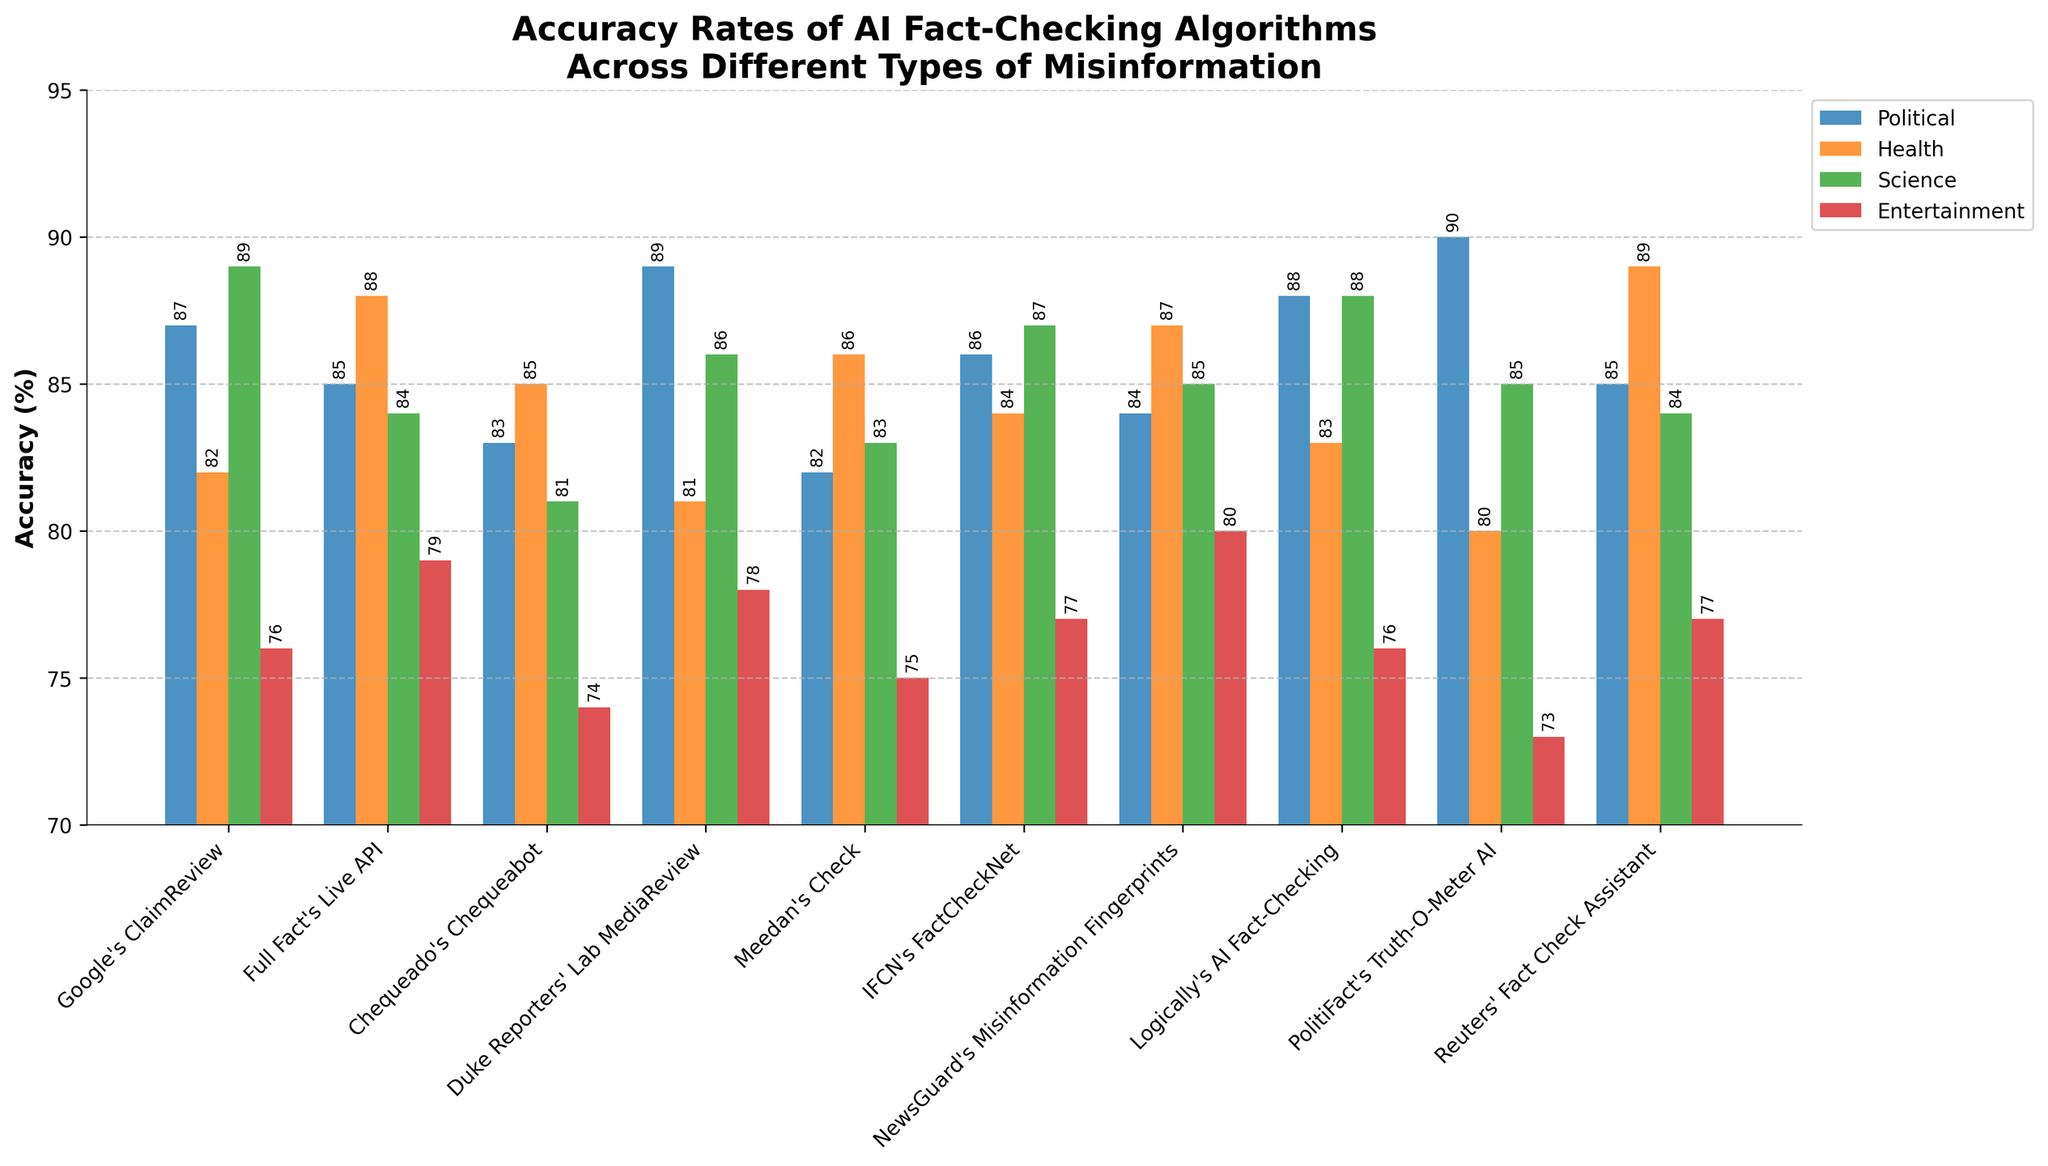Which algorithm has the highest accuracy rate for political misinformation? To find the highest accuracy rate for political misinformation, look at the heights (values) of the blue bars. Identify the tallest blue bar which corresponds to PolitiFact’s Truth-O-Meter AI.
Answer: PolitiFact's Truth-O-Meter AI Which algorithm is closest to achieving an 85% accuracy rate across all types of misinformation? To determine this, average the accuracy rates for each algorithm and compare the averaged value to 85%. The algorithm closest to this average is Reuters' Fact Check Assistant (85+89+84+77)/4 = 83.75.
Answer: Reuters' Fact Check Assistant Which category of misinformation shows the highest variance in accuracy rates among the algorithms? Find the range (difference between the highest and lowest values) for each category by identifying the highest and lowest values for each group's colored bar: Political has a range of 90-82=8, Health has 89-80=9, Science has 89-81=8, and Entertainment has 80-73=7. Health has the highest variance.
Answer: Health Among Google's ClaimReview and Logically's AI Fact-Checking, which has a higher accuracy rate for health-related misinformation? Compare the heights of the orange bars for these two algorithms. Logically's AI Fact-Checking has an accuracy rate of 83%, whereas Google's ClaimReview has an accuracy rate of 82%.
Answer: Logically's AI Fact-Checking Which type of misinformation has the lowest average accuracy rate across all algorithms? Compute the average accuracy rate for each type of misinformation: Political: (87+85+83+89+82+86+84+88+90+85)/10=85.9, Health: (82+88+85+81+86+84+87+83+80+89)/10=84.5, Science: (89+84+81+86+83+87+85+88+85+84)/10=85.2, Entertainment: (76+79+74+78+75+77+80+76+73+77)/10=76.5. Entertainment has the lowest average accuracy rate.
Answer: Entertainment For which type of misinformation does Duke Reporters' Lab MediaReview have the highest accuracy rate when compared to other algorithms? Compare Duke Reporters' Lab MediaReview's accuracy rates across all types of misinformation. For each type, check if its value is the highest compared to others. It has the highest rate in the Political category with 89%.
Answer: Political Does Full Fact's Live API have a higher accuracy rate for health misinformation compared to science misinformation? Compare the heights of the orange and green bars for Full Fact's Live API. The health accuracy rate is 88%, and the science accuracy rate is 84%.
Answer: Yes What is the difference in accuracy rates for political misinformation between Chequeado's Chequeabot and Meedan's Check? Identify the heights of the blue bars for Chequeado's Chequeabot and Meedan's Check. Chequeado's Chequeabot is at 83%, and Meedan's Check is at 82%. The difference is 83-82=1.
Answer: 1 Which algorithm has the least accurate performance in the entertainment category? Identify the shortest red bar in the graph, which corresponds to PolitiFact's Truth-O-Meter AI.
Answer: PolitiFact's Truth-O-Meter AI What's the overall trend for entertainment misinformation accuracy rates as compared to other categories? Visually assess the heights of the red bars compared to other categories' bars. Red bars appear consistently lower than the others, indicating overall lower accuracy rates for entertainment misinformation across algorithms.
Answer: Lower 